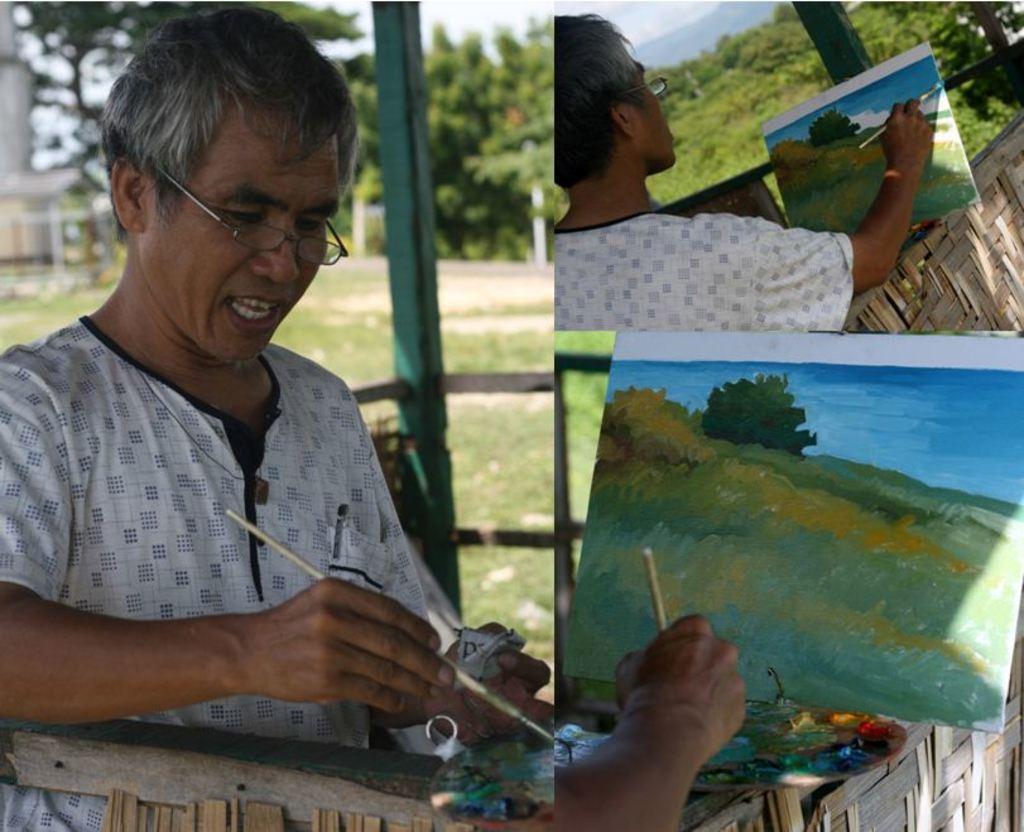How would you summarize this image in a sentence or two? In this image I can see two persons are painting on a paper with brush. In the background I can see trees, fence and the sky. This image is taken during a day. 